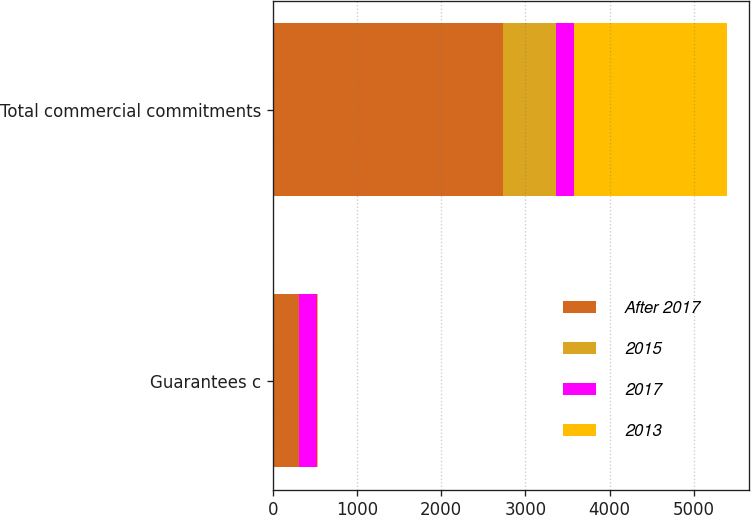Convert chart to OTSL. <chart><loc_0><loc_0><loc_500><loc_500><stacked_bar_chart><ecel><fcel>Guarantees c<fcel>Total commercial commitments<nl><fcel>After 2017<fcel>307<fcel>2732<nl><fcel>2015<fcel>8<fcel>632<nl><fcel>2017<fcel>214<fcel>215<nl><fcel>2013<fcel>12<fcel>1812<nl></chart> 